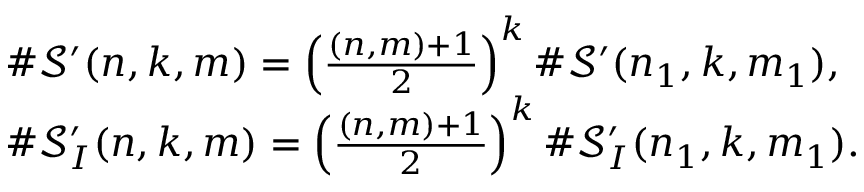Convert formula to latex. <formula><loc_0><loc_0><loc_500><loc_500>\begin{array} { r l } & { \# \mathcal { S } ^ { \prime } ( n , k , m ) = \left ( \frac { ( n , m ) + 1 } { 2 } \right ) ^ { k } \# \mathcal { S } ^ { \prime } ( n _ { 1 } , k , m _ { 1 } ) , } \\ & { \# \mathcal { S } _ { I } ^ { \prime } ( n , k , m ) = \left ( \frac { ( n , m ) + 1 } { 2 } \right ) ^ { k } \# \mathcal { S } _ { I } ^ { \prime } ( n _ { 1 } , k , m _ { 1 } ) . } \end{array}</formula> 